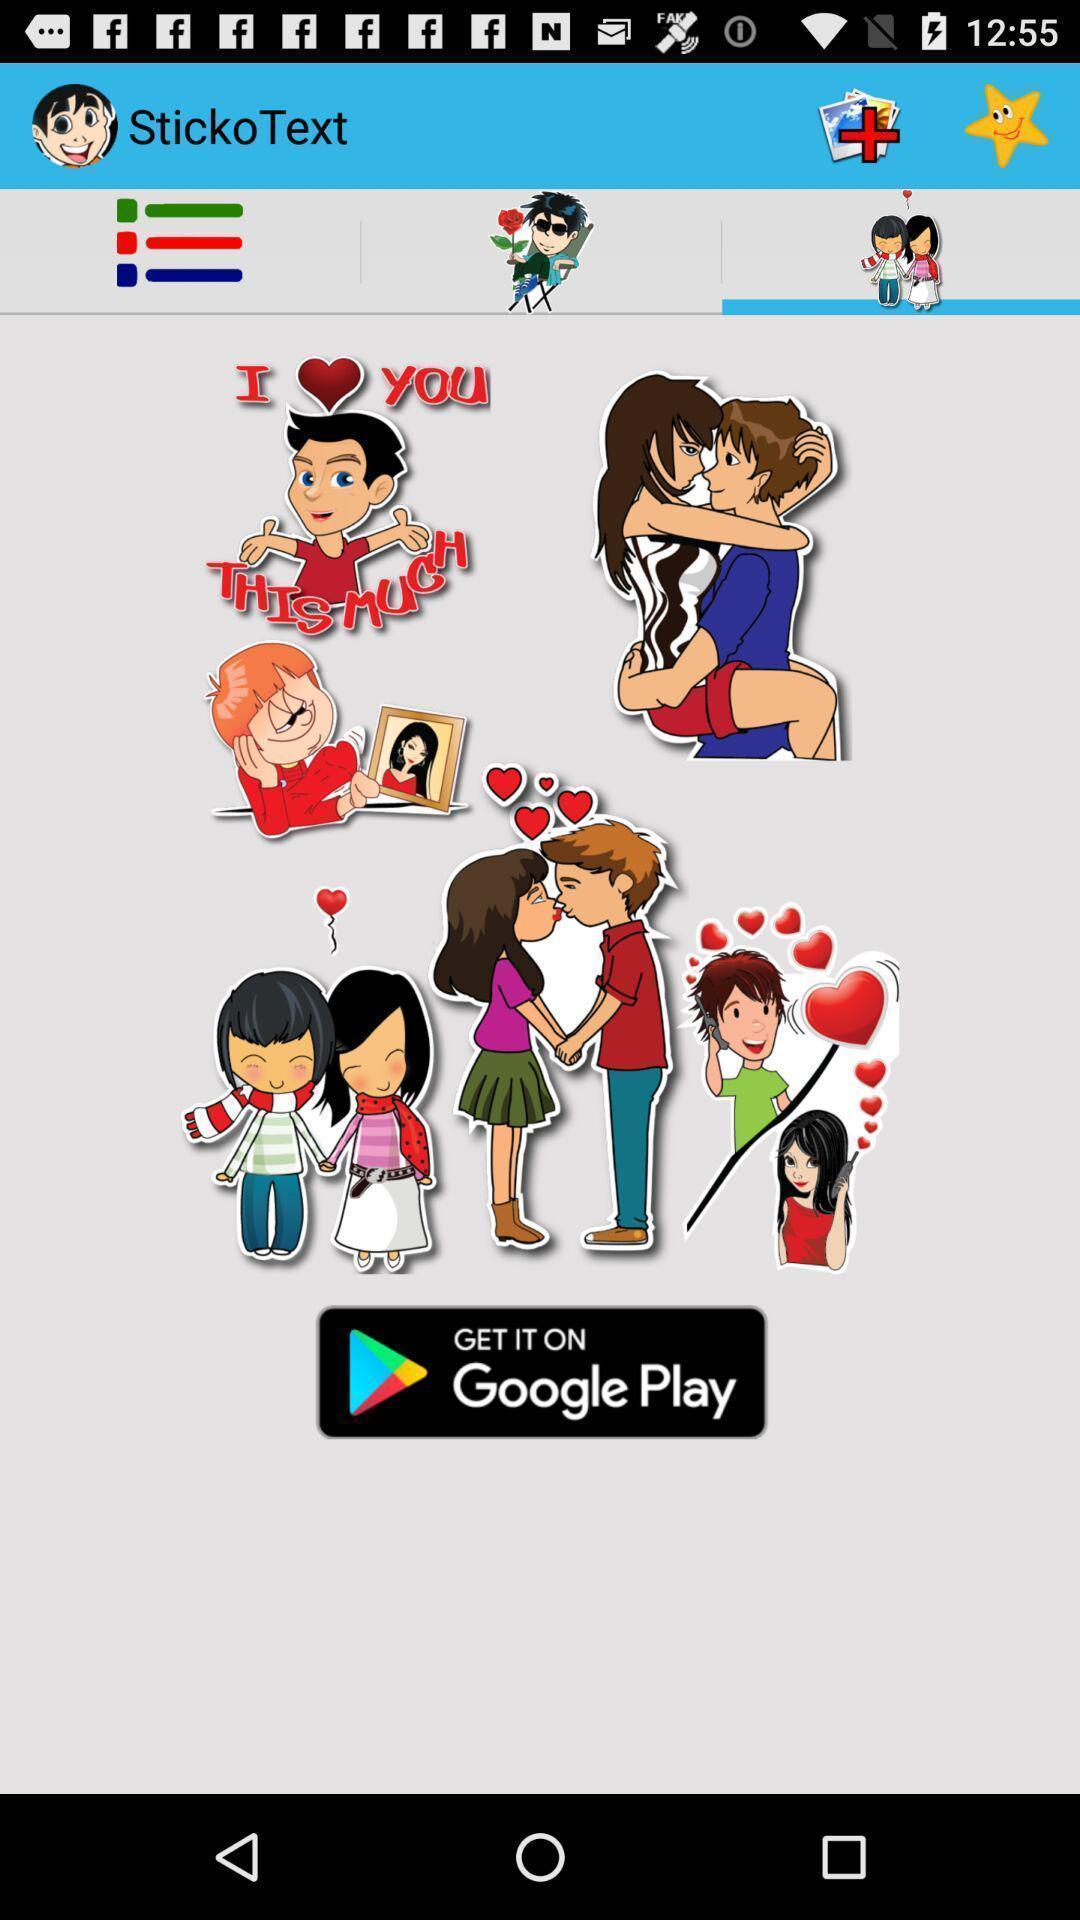Provide a detailed account of this screenshot. Screen shows multiple options. 